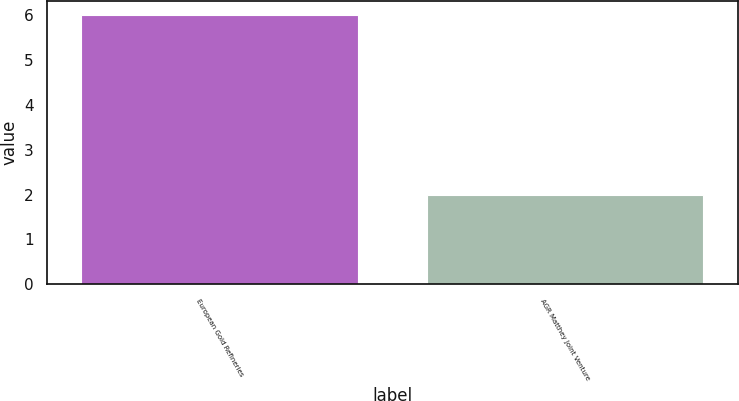Convert chart. <chart><loc_0><loc_0><loc_500><loc_500><bar_chart><fcel>European Gold Refineries<fcel>AGR Matthey Joint Venture<nl><fcel>6<fcel>2<nl></chart> 